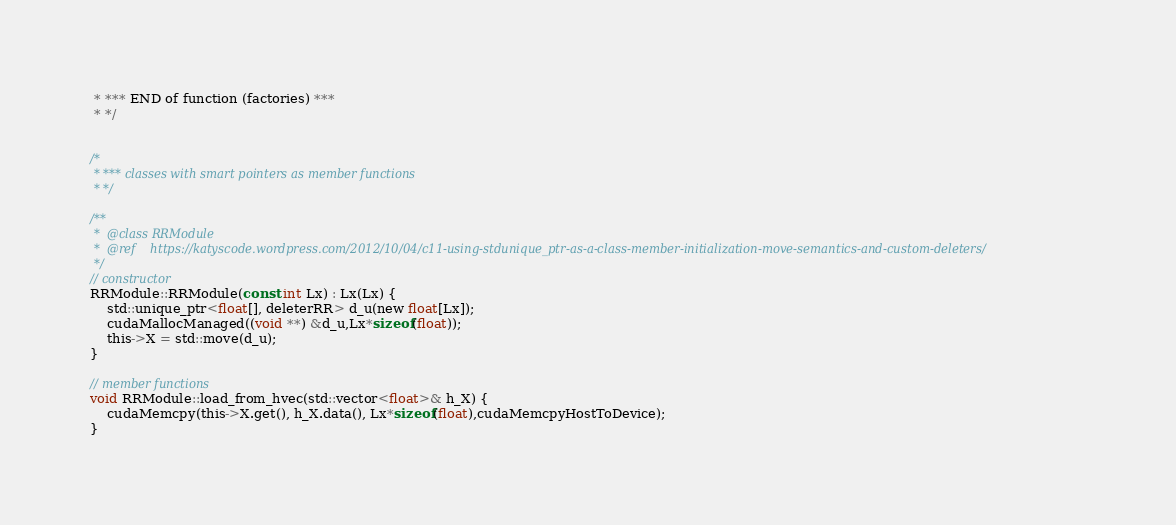<code> <loc_0><loc_0><loc_500><loc_500><_Cuda_> * *** END of function (factories) ***
 * */
 
 
/*
 * *** classes with smart pointers as member functions
 * */ 

/** 
 * 	@class RRModule
 * 	@ref	https://katyscode.wordpress.com/2012/10/04/c11-using-stdunique_ptr-as-a-class-member-initialization-move-semantics-and-custom-deleters/
 */
// constructor 
RRModule::RRModule(const int Lx) : Lx(Lx) {
	std::unique_ptr<float[], deleterRR> d_u(new float[Lx]);
	cudaMallocManaged((void **) &d_u,Lx*sizeof(float));
	this->X = std::move(d_u);
}

// member functions
void RRModule::load_from_hvec(std::vector<float>& h_X) {
	cudaMemcpy(this->X.get(), h_X.data(), Lx*sizeof(float),cudaMemcpyHostToDevice);	
}	
</code> 